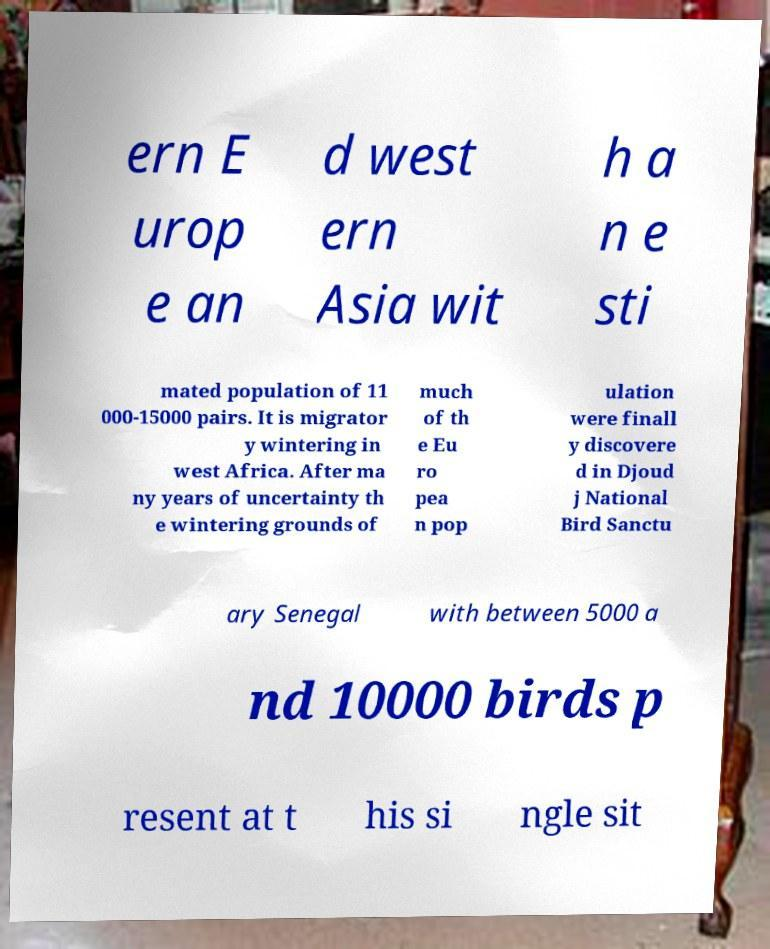Can you read and provide the text displayed in the image?This photo seems to have some interesting text. Can you extract and type it out for me? ern E urop e an d west ern Asia wit h a n e sti mated population of 11 000-15000 pairs. It is migrator y wintering in west Africa. After ma ny years of uncertainty th e wintering grounds of much of th e Eu ro pea n pop ulation were finall y discovere d in Djoud j National Bird Sanctu ary Senegal with between 5000 a nd 10000 birds p resent at t his si ngle sit 